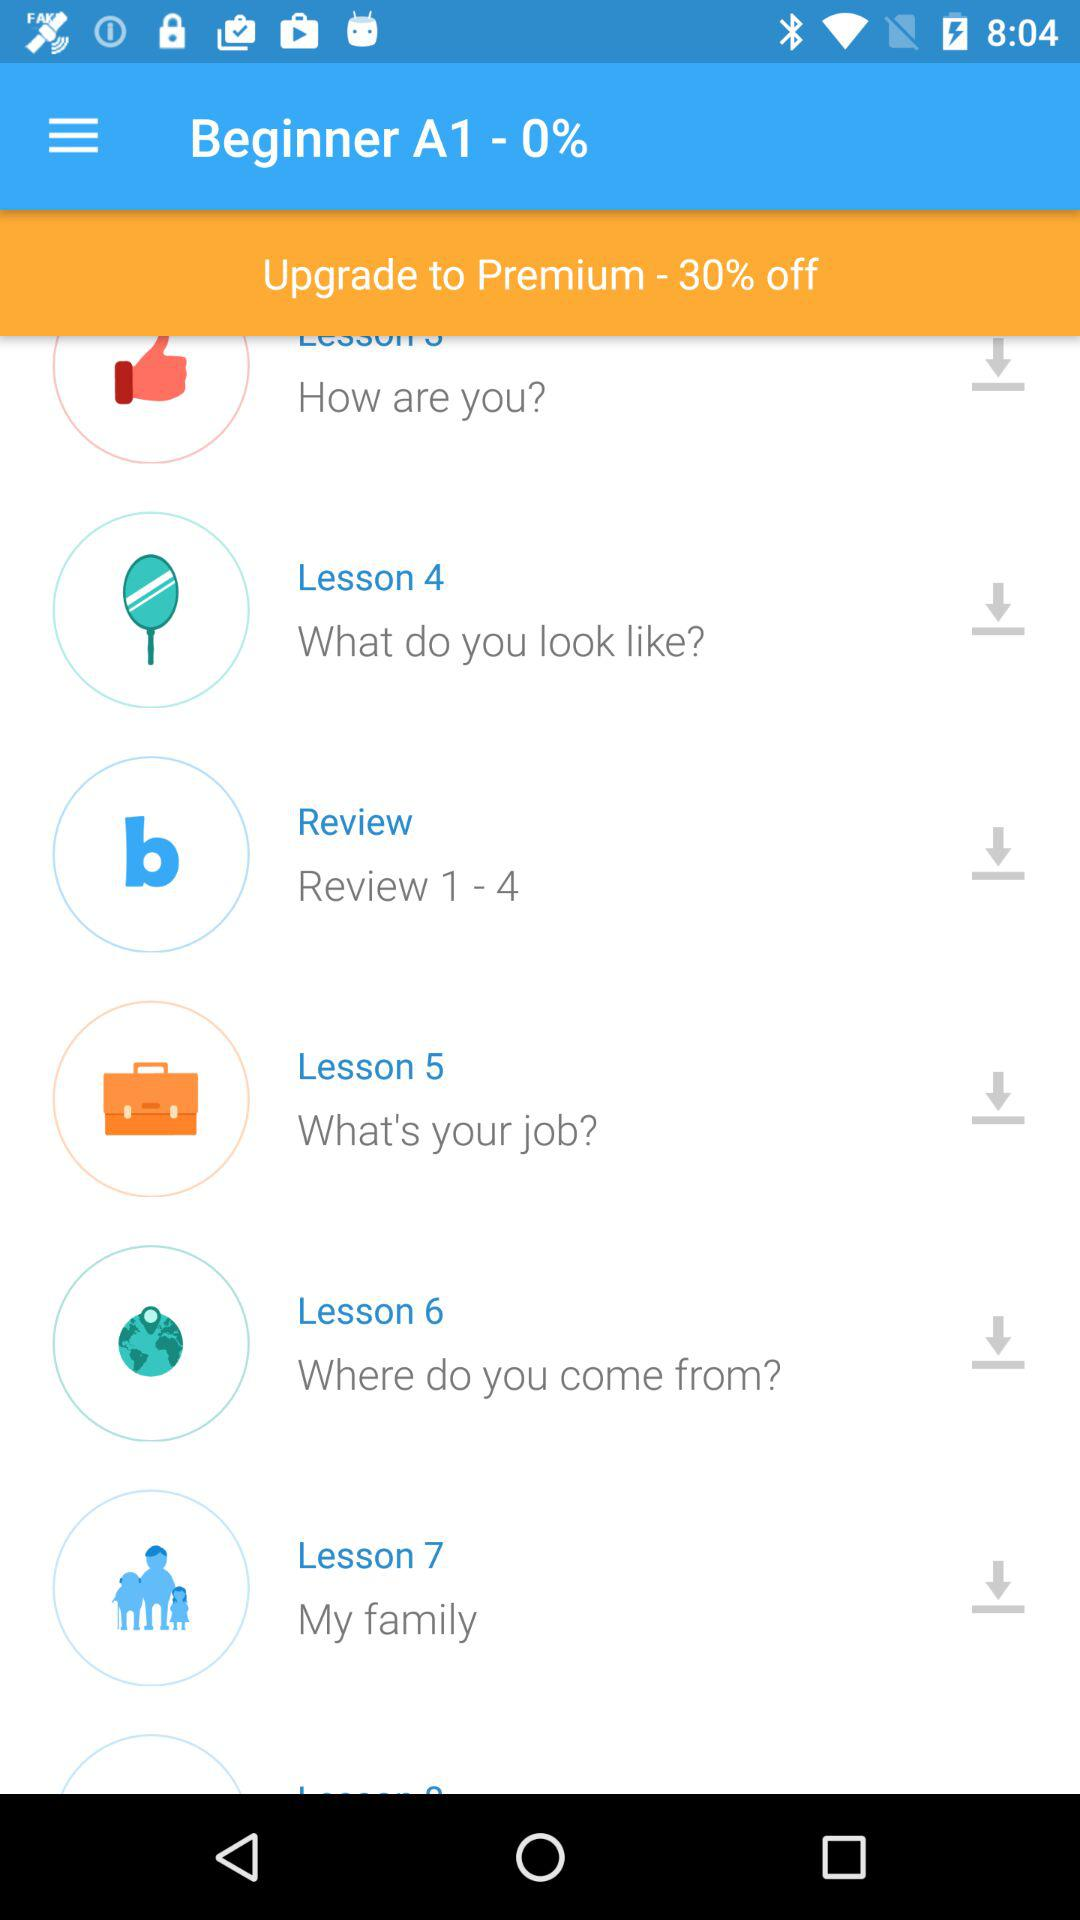What is the lesson number for "What do you look like"? The lesson number is 4. 